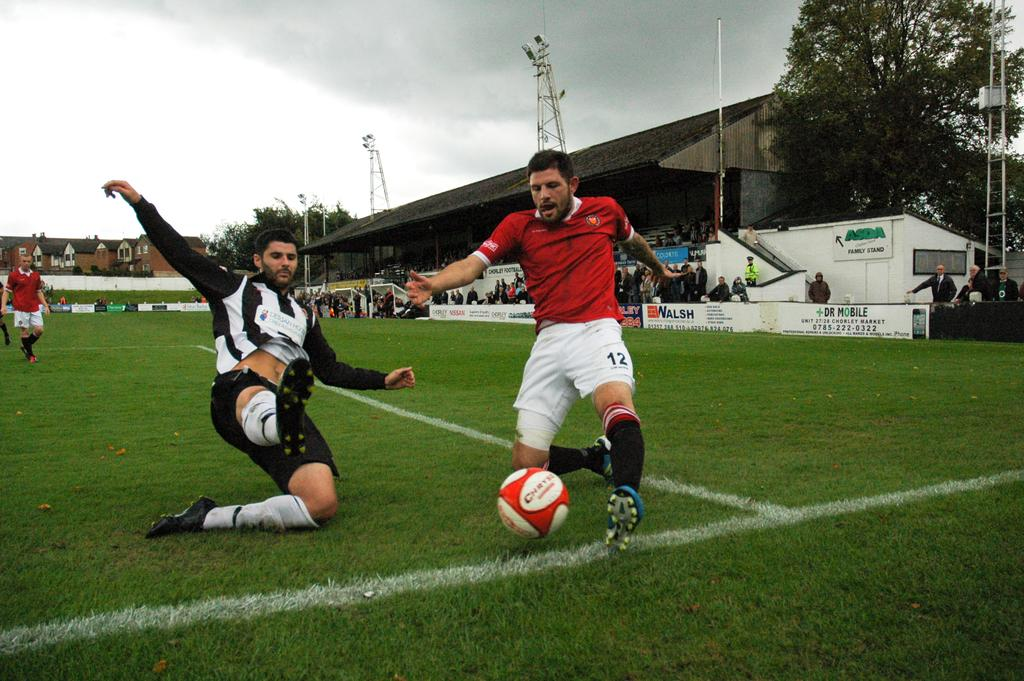<image>
Summarize the visual content of the image. Two teams playing soccer with an advertisement for Dr Mobile in the background. 